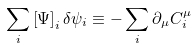Convert formula to latex. <formula><loc_0><loc_0><loc_500><loc_500>\sum _ { i } \left [ \Psi \right ] _ { i } \delta \psi _ { i } \equiv - \sum _ { i } \partial _ { \mu } C _ { i } ^ { \mu }</formula> 